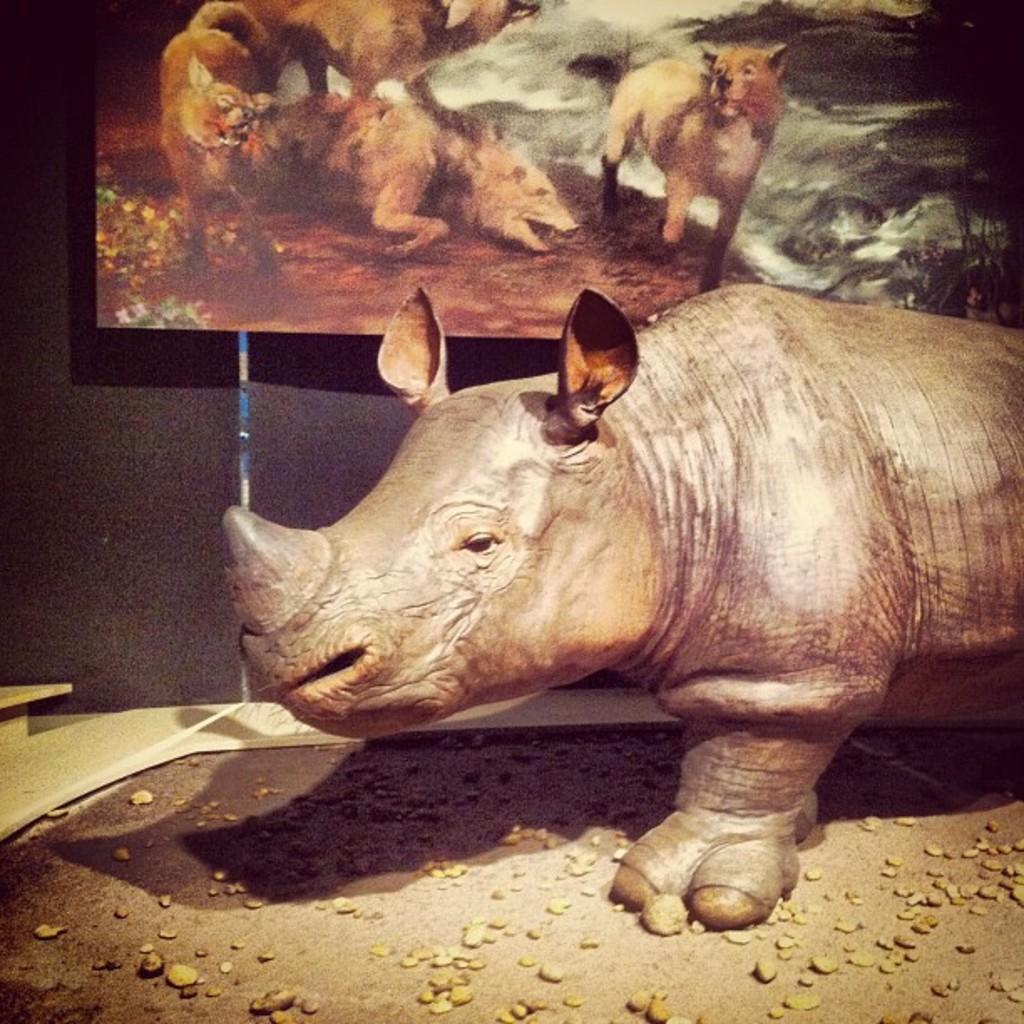Describe this image in one or two sentences. Here in this picture, in the front we can see a statue of a Rhinoceros present on the ground and beside that on the wall we can see a painting present. 